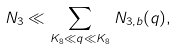<formula> <loc_0><loc_0><loc_500><loc_500>N _ { 3 } \ll \sum _ { K _ { 8 } \ll q \ll K _ { 8 } } N _ { 3 , b } ( q ) ,</formula> 